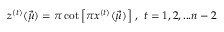Convert formula to latex. <formula><loc_0><loc_0><loc_500><loc_500>z ^ { ( t ) } ( \vec { \mu } ) = \pi \cot \left [ \pi x ^ { ( t ) } ( \vec { \mu } ) \right ] \, , \, t = 1 , 2 , \dots n - 2 \,</formula> 